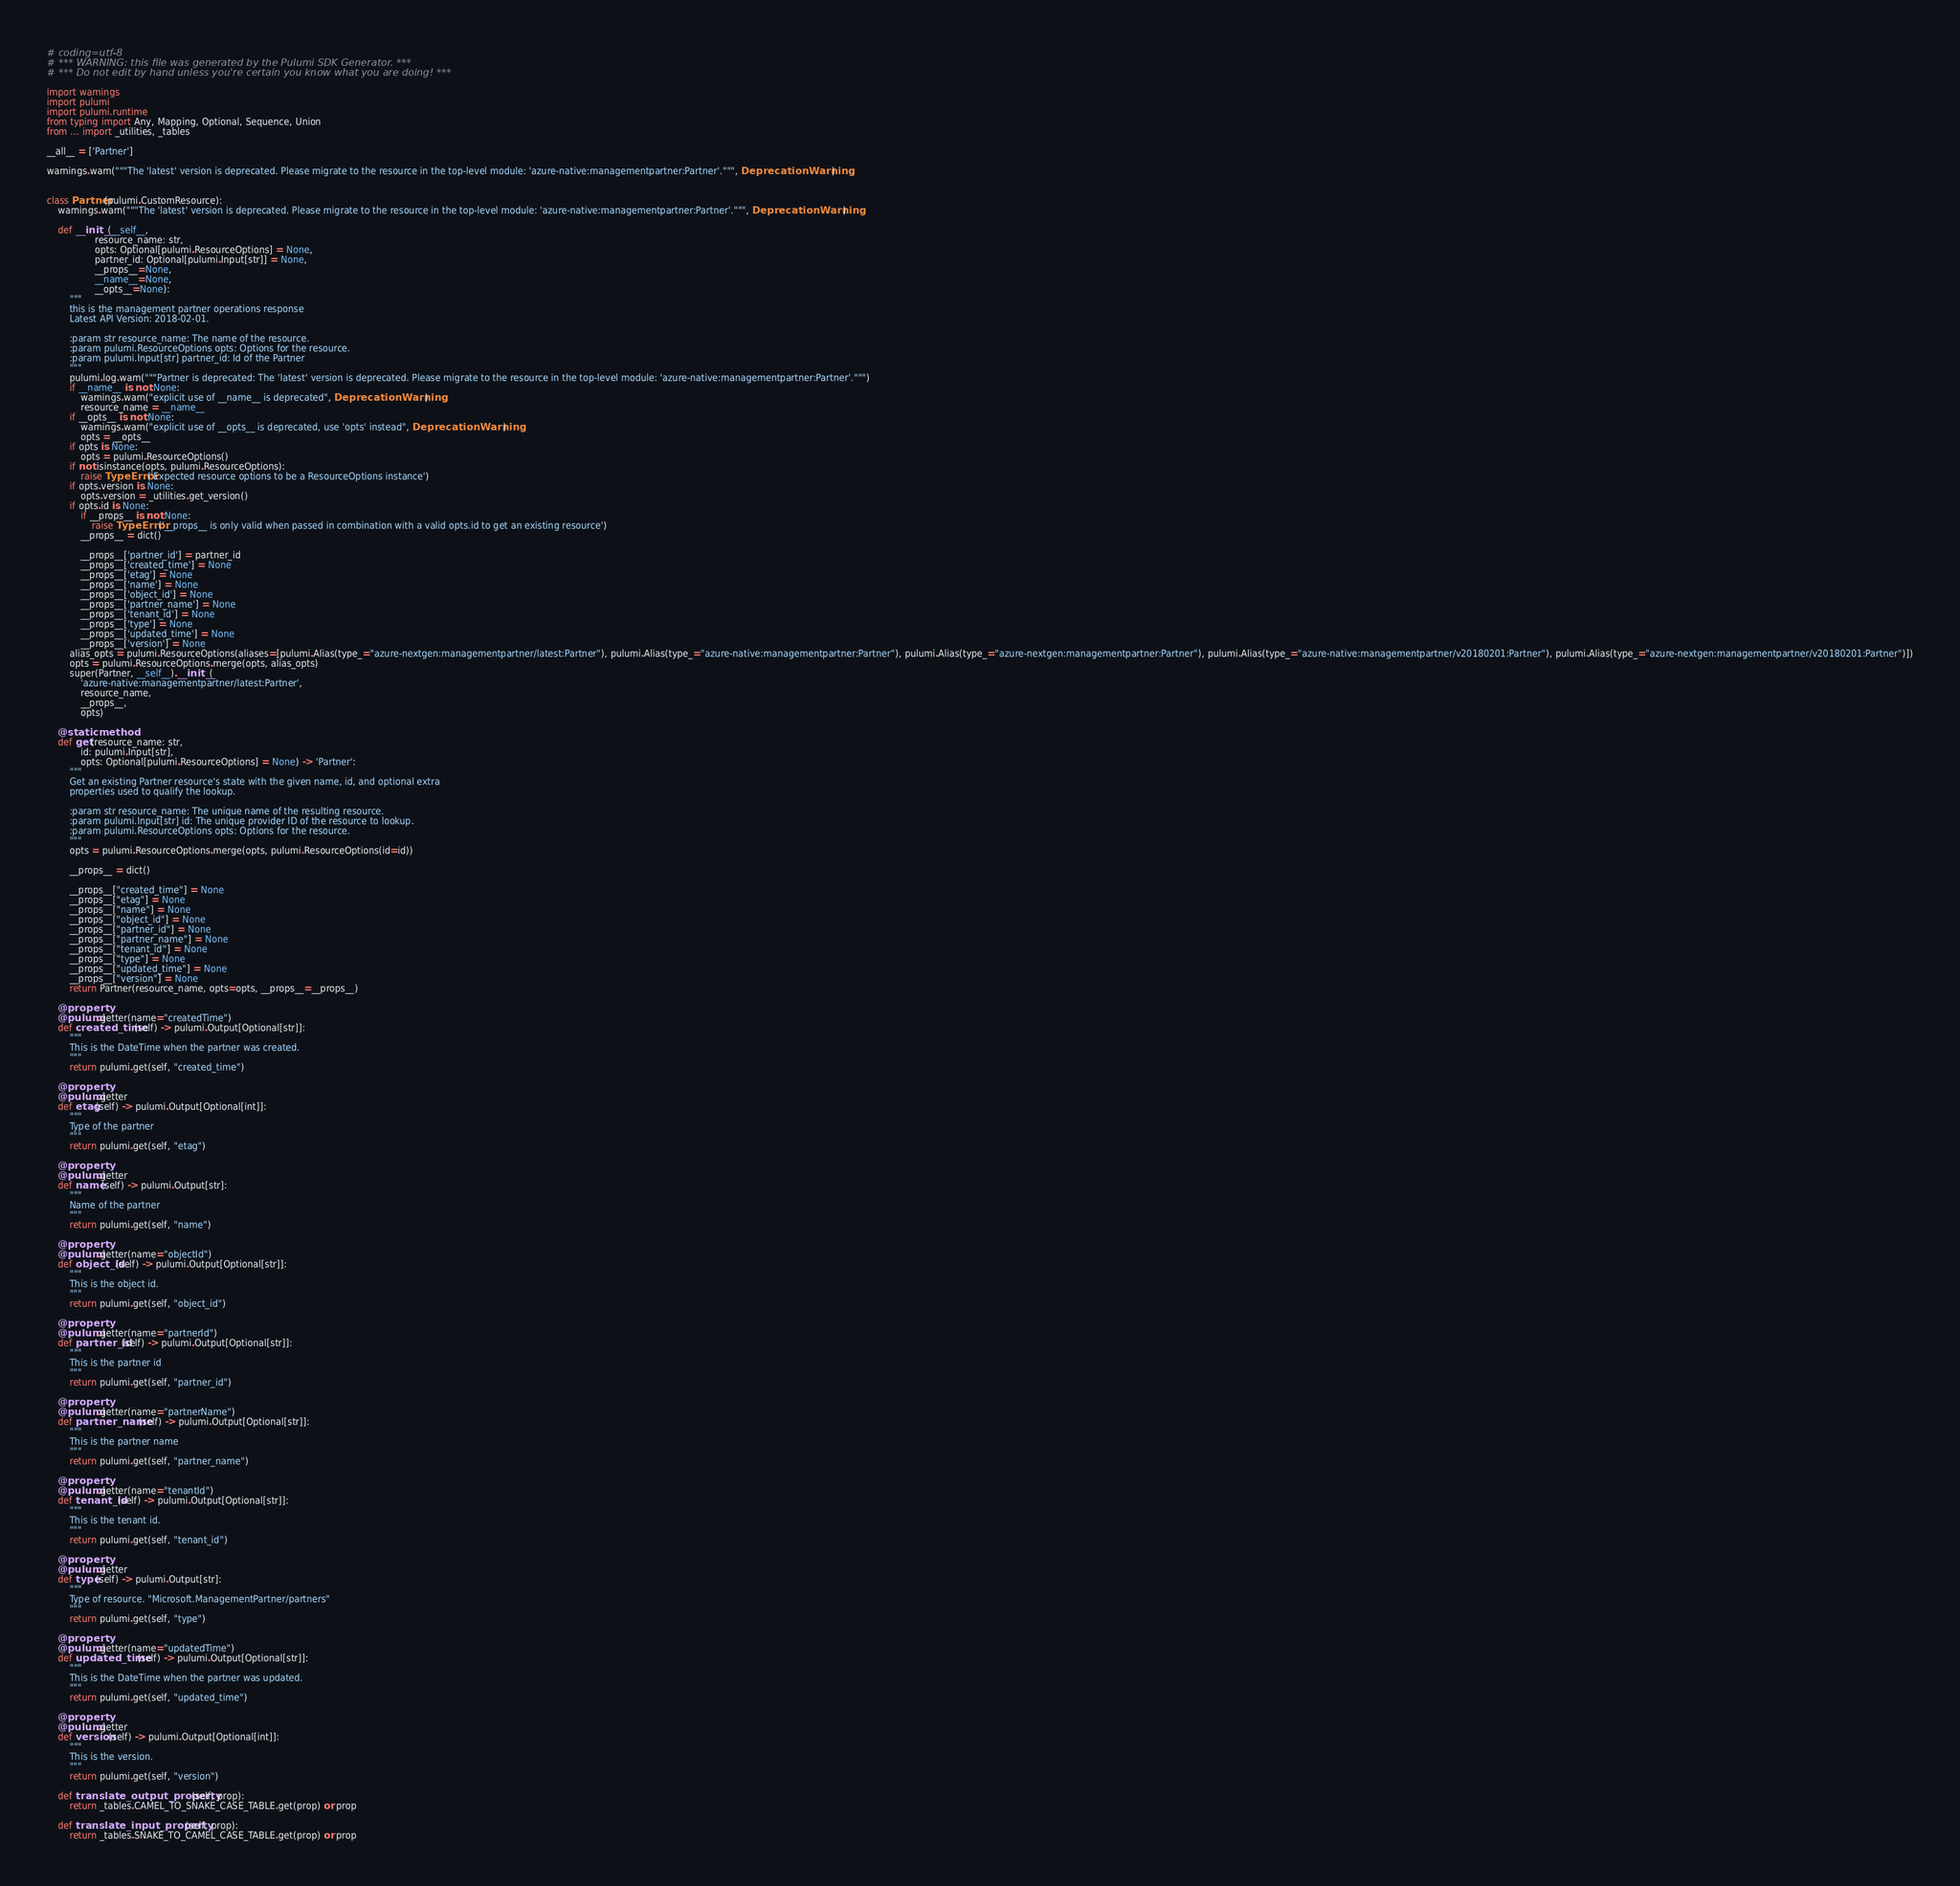<code> <loc_0><loc_0><loc_500><loc_500><_Python_># coding=utf-8
# *** WARNING: this file was generated by the Pulumi SDK Generator. ***
# *** Do not edit by hand unless you're certain you know what you are doing! ***

import warnings
import pulumi
import pulumi.runtime
from typing import Any, Mapping, Optional, Sequence, Union
from ... import _utilities, _tables

__all__ = ['Partner']

warnings.warn("""The 'latest' version is deprecated. Please migrate to the resource in the top-level module: 'azure-native:managementpartner:Partner'.""", DeprecationWarning)


class Partner(pulumi.CustomResource):
    warnings.warn("""The 'latest' version is deprecated. Please migrate to the resource in the top-level module: 'azure-native:managementpartner:Partner'.""", DeprecationWarning)

    def __init__(__self__,
                 resource_name: str,
                 opts: Optional[pulumi.ResourceOptions] = None,
                 partner_id: Optional[pulumi.Input[str]] = None,
                 __props__=None,
                 __name__=None,
                 __opts__=None):
        """
        this is the management partner operations response
        Latest API Version: 2018-02-01.

        :param str resource_name: The name of the resource.
        :param pulumi.ResourceOptions opts: Options for the resource.
        :param pulumi.Input[str] partner_id: Id of the Partner
        """
        pulumi.log.warn("""Partner is deprecated: The 'latest' version is deprecated. Please migrate to the resource in the top-level module: 'azure-native:managementpartner:Partner'.""")
        if __name__ is not None:
            warnings.warn("explicit use of __name__ is deprecated", DeprecationWarning)
            resource_name = __name__
        if __opts__ is not None:
            warnings.warn("explicit use of __opts__ is deprecated, use 'opts' instead", DeprecationWarning)
            opts = __opts__
        if opts is None:
            opts = pulumi.ResourceOptions()
        if not isinstance(opts, pulumi.ResourceOptions):
            raise TypeError('Expected resource options to be a ResourceOptions instance')
        if opts.version is None:
            opts.version = _utilities.get_version()
        if opts.id is None:
            if __props__ is not None:
                raise TypeError('__props__ is only valid when passed in combination with a valid opts.id to get an existing resource')
            __props__ = dict()

            __props__['partner_id'] = partner_id
            __props__['created_time'] = None
            __props__['etag'] = None
            __props__['name'] = None
            __props__['object_id'] = None
            __props__['partner_name'] = None
            __props__['tenant_id'] = None
            __props__['type'] = None
            __props__['updated_time'] = None
            __props__['version'] = None
        alias_opts = pulumi.ResourceOptions(aliases=[pulumi.Alias(type_="azure-nextgen:managementpartner/latest:Partner"), pulumi.Alias(type_="azure-native:managementpartner:Partner"), pulumi.Alias(type_="azure-nextgen:managementpartner:Partner"), pulumi.Alias(type_="azure-native:managementpartner/v20180201:Partner"), pulumi.Alias(type_="azure-nextgen:managementpartner/v20180201:Partner")])
        opts = pulumi.ResourceOptions.merge(opts, alias_opts)
        super(Partner, __self__).__init__(
            'azure-native:managementpartner/latest:Partner',
            resource_name,
            __props__,
            opts)

    @staticmethod
    def get(resource_name: str,
            id: pulumi.Input[str],
            opts: Optional[pulumi.ResourceOptions] = None) -> 'Partner':
        """
        Get an existing Partner resource's state with the given name, id, and optional extra
        properties used to qualify the lookup.

        :param str resource_name: The unique name of the resulting resource.
        :param pulumi.Input[str] id: The unique provider ID of the resource to lookup.
        :param pulumi.ResourceOptions opts: Options for the resource.
        """
        opts = pulumi.ResourceOptions.merge(opts, pulumi.ResourceOptions(id=id))

        __props__ = dict()

        __props__["created_time"] = None
        __props__["etag"] = None
        __props__["name"] = None
        __props__["object_id"] = None
        __props__["partner_id"] = None
        __props__["partner_name"] = None
        __props__["tenant_id"] = None
        __props__["type"] = None
        __props__["updated_time"] = None
        __props__["version"] = None
        return Partner(resource_name, opts=opts, __props__=__props__)

    @property
    @pulumi.getter(name="createdTime")
    def created_time(self) -> pulumi.Output[Optional[str]]:
        """
        This is the DateTime when the partner was created.
        """
        return pulumi.get(self, "created_time")

    @property
    @pulumi.getter
    def etag(self) -> pulumi.Output[Optional[int]]:
        """
        Type of the partner
        """
        return pulumi.get(self, "etag")

    @property
    @pulumi.getter
    def name(self) -> pulumi.Output[str]:
        """
        Name of the partner
        """
        return pulumi.get(self, "name")

    @property
    @pulumi.getter(name="objectId")
    def object_id(self) -> pulumi.Output[Optional[str]]:
        """
        This is the object id.
        """
        return pulumi.get(self, "object_id")

    @property
    @pulumi.getter(name="partnerId")
    def partner_id(self) -> pulumi.Output[Optional[str]]:
        """
        This is the partner id
        """
        return pulumi.get(self, "partner_id")

    @property
    @pulumi.getter(name="partnerName")
    def partner_name(self) -> pulumi.Output[Optional[str]]:
        """
        This is the partner name
        """
        return pulumi.get(self, "partner_name")

    @property
    @pulumi.getter(name="tenantId")
    def tenant_id(self) -> pulumi.Output[Optional[str]]:
        """
        This is the tenant id.
        """
        return pulumi.get(self, "tenant_id")

    @property
    @pulumi.getter
    def type(self) -> pulumi.Output[str]:
        """
        Type of resource. "Microsoft.ManagementPartner/partners"
        """
        return pulumi.get(self, "type")

    @property
    @pulumi.getter(name="updatedTime")
    def updated_time(self) -> pulumi.Output[Optional[str]]:
        """
        This is the DateTime when the partner was updated.
        """
        return pulumi.get(self, "updated_time")

    @property
    @pulumi.getter
    def version(self) -> pulumi.Output[Optional[int]]:
        """
        This is the version.
        """
        return pulumi.get(self, "version")

    def translate_output_property(self, prop):
        return _tables.CAMEL_TO_SNAKE_CASE_TABLE.get(prop) or prop

    def translate_input_property(self, prop):
        return _tables.SNAKE_TO_CAMEL_CASE_TABLE.get(prop) or prop

</code> 